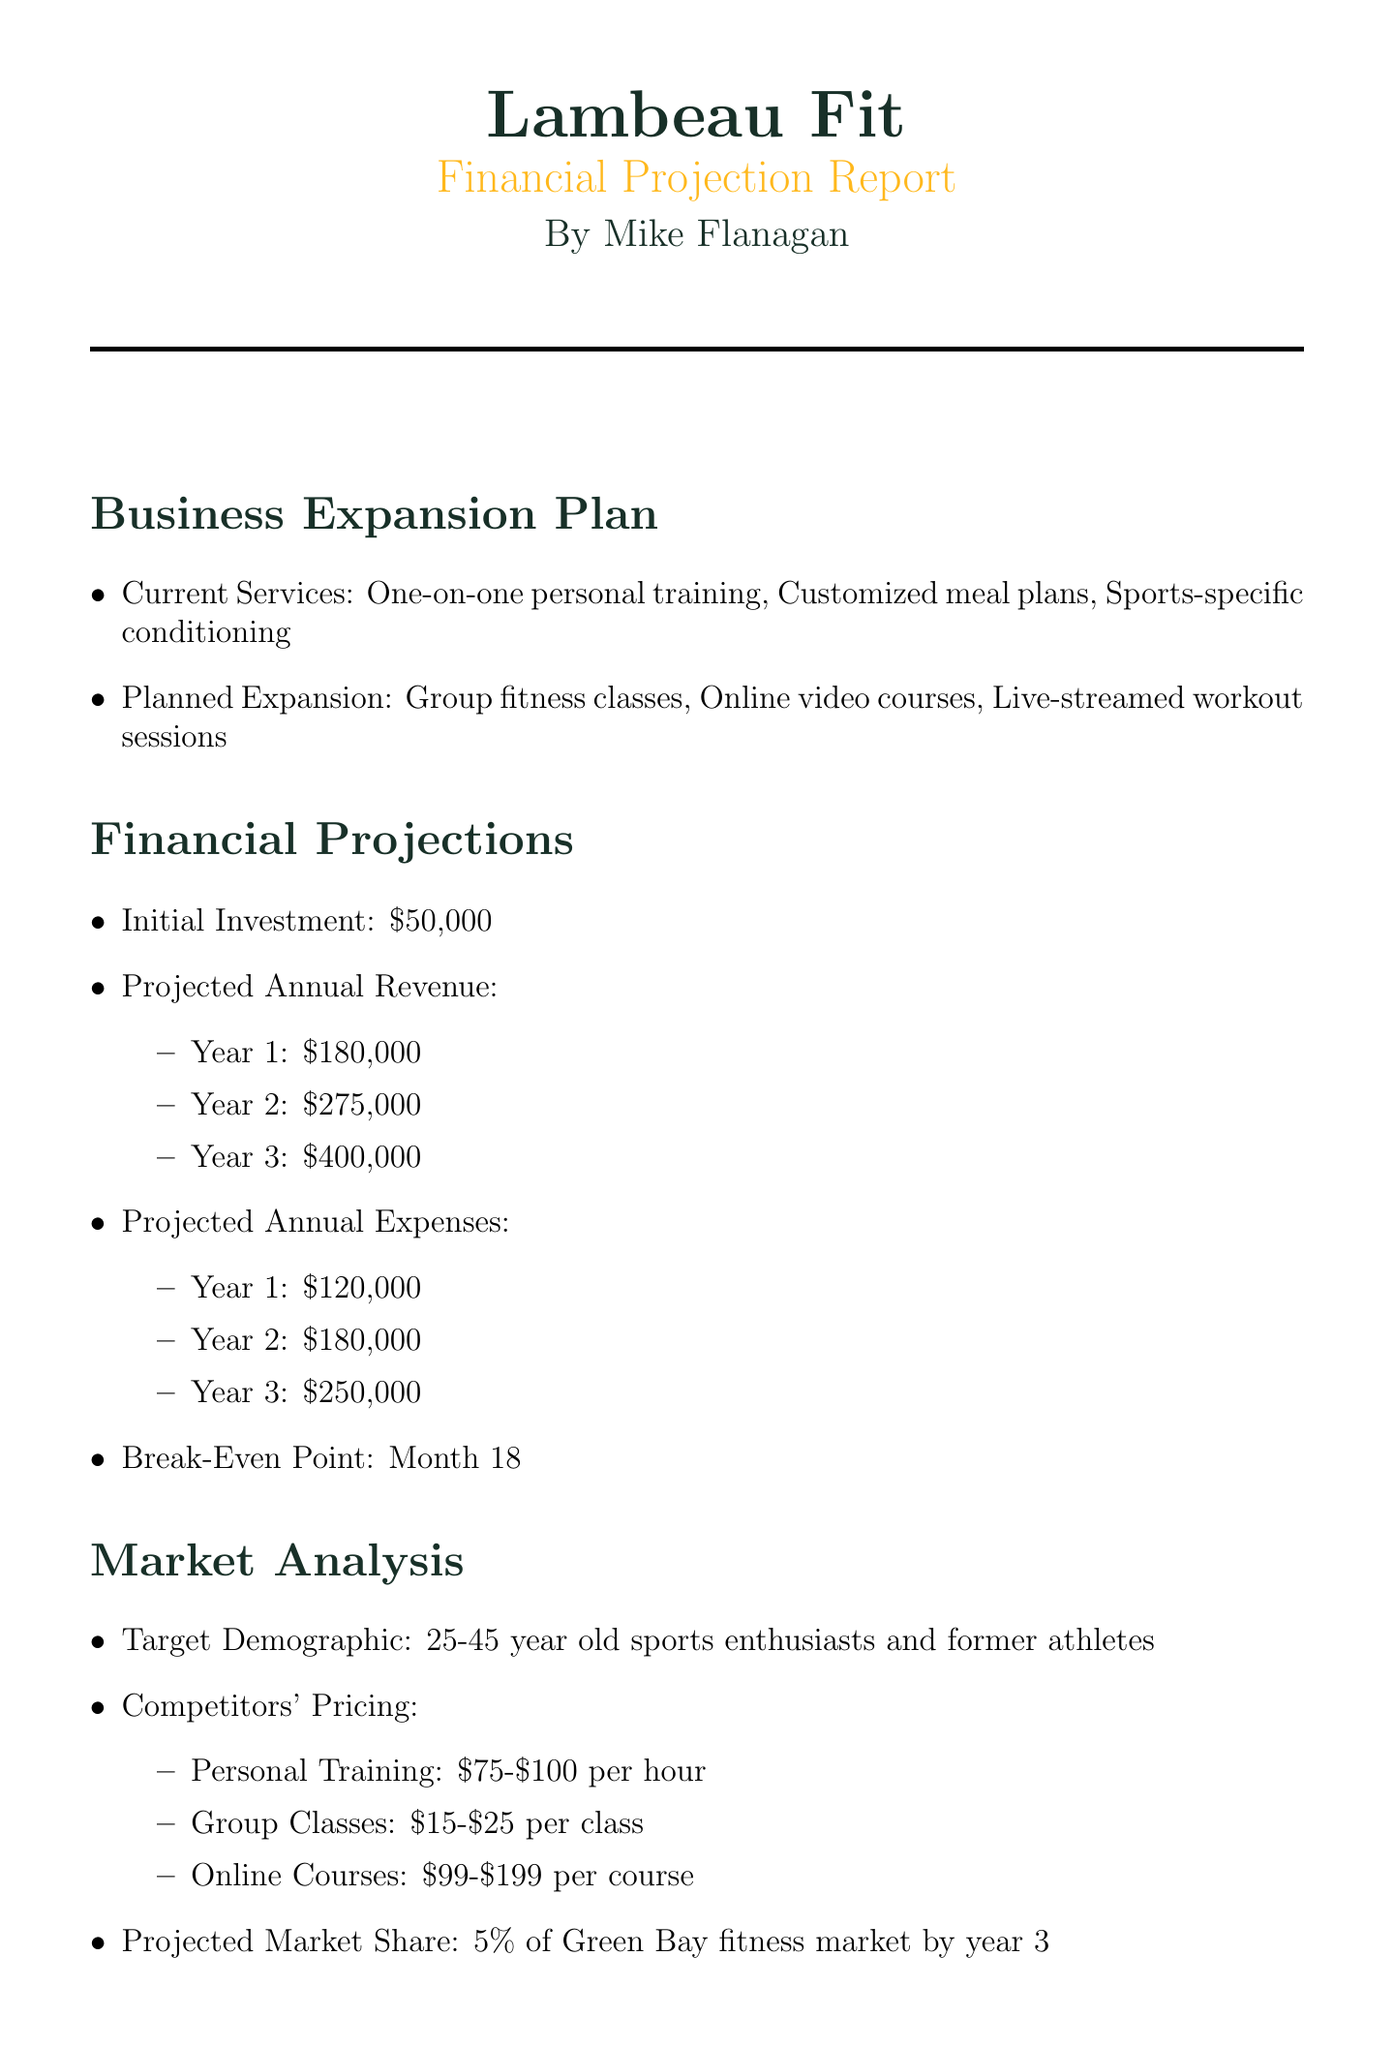What is the initial investment? The initial investment is specifically stated in the financial projections section of the document.
Answer: $50,000 What are the planned expansions for the business? The document outlines several planned expansions under the business expansion plan section.
Answer: Group fitness classes, Online video courses, Live-streamed workout sessions What is the projected market share by year 3? The document mentions the projected market share in the market analysis section.
Answer: 5% of Green Bay fitness market by year 3 What is the break-even point? The break-even point is outlined in the financial projections section as the time frame for recovering initial investments.
Answer: Month 18 What additional staff positions are needed? The operational costs section lists specific additional staffing needs for the business.
Answer: 2 additional trainers, 1 videographer, 1 online content manager What is the projected annual revenue for year 2? The document includes a projection for annual revenue in the financial projections section.
Answer: $275,000 What are the revenue streams listed? The document specifies various revenue streams in a designated section of the report.
Answer: Monthly membership fees, Pay-per-class options, Online course sales, Branded merchandise What is a potential risk factor mentioned? The risk factors section of the document outlines challenges that could impact the business.
Answer: Seasonal fluctuations in demand 